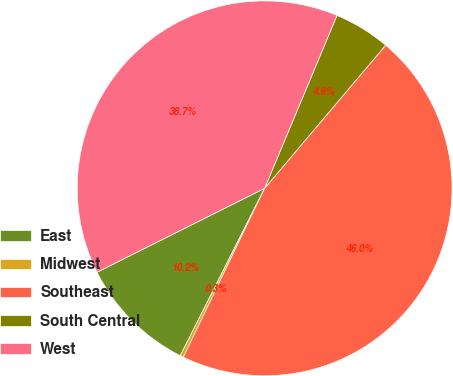<chart> <loc_0><loc_0><loc_500><loc_500><pie_chart><fcel>East<fcel>Midwest<fcel>Southeast<fcel>South Central<fcel>West<nl><fcel>10.18%<fcel>0.29%<fcel>45.97%<fcel>4.86%<fcel>38.7%<nl></chart> 